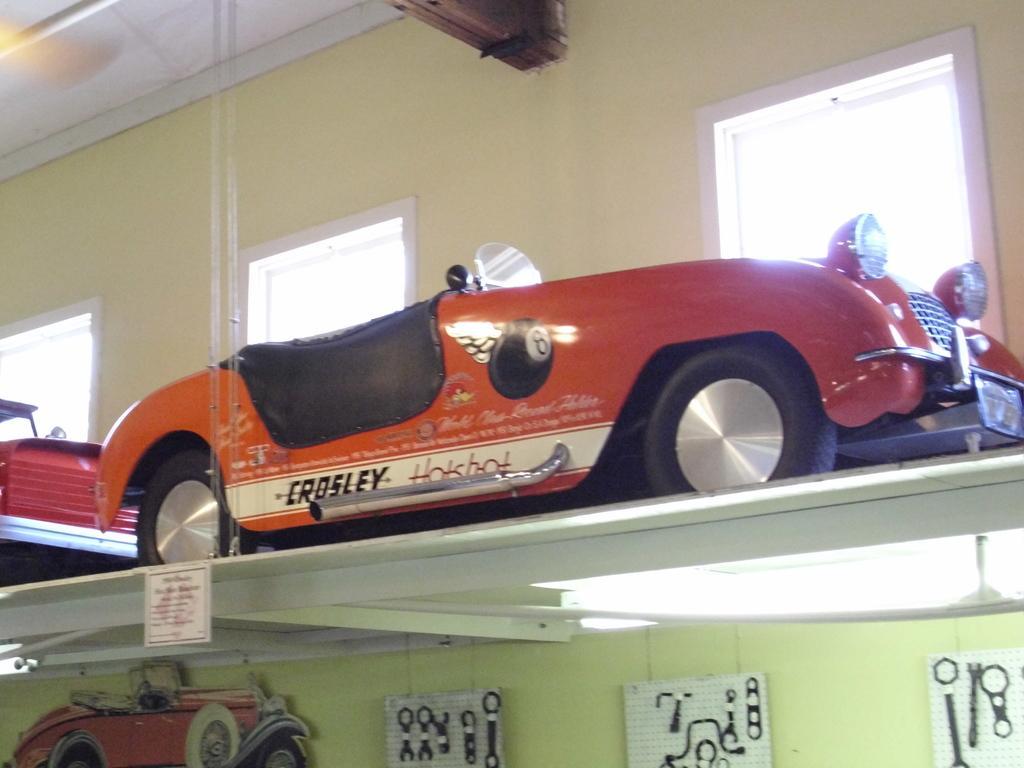Please provide a concise description of this image. In this picture we can see toy vehicles on a shelf, posters on the wall, name board and in the background we can see windows, ceiling. 